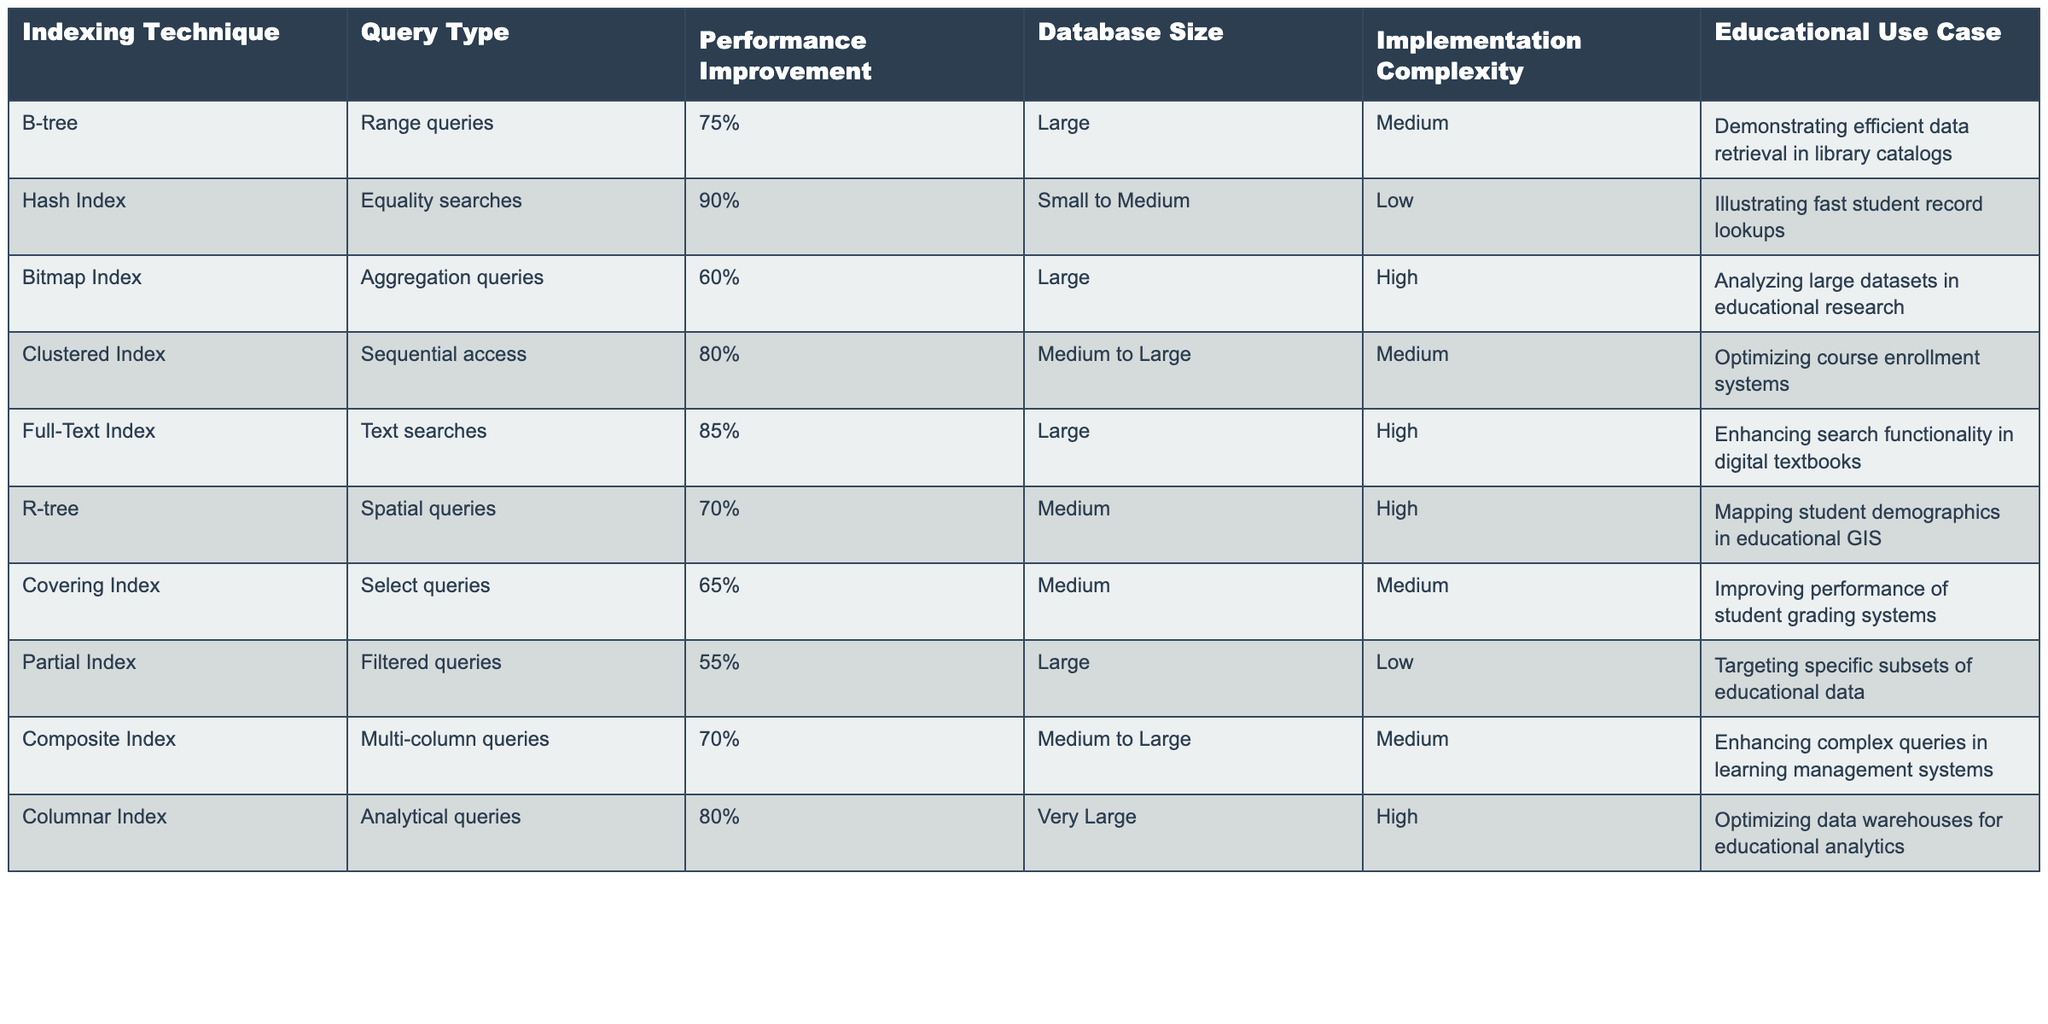What is the performance improvement percentage for B-tree indexing technique? The table shows that the performance improvement for B-tree indexing technique is 75%. This is directly referenced from the corresponding cell under the "Performance Improvement" column for the B-tree row.
Answer: 75% Which indexing technique has the lowest implementation complexity? By examining the "Implementation Complexity" column, the Hash Index technique has a low complexity rating as compared to others like Bitmap Index and Full-Text Index which have high complexity.
Answer: Hash Index What are the average performance improvements of indexes for equality searches versus range queries? The performance improvement for equality searches (Hash Index) is 90%, while for range queries (B-tree) it is 75%. The average for equality searches is 90%, and for range queries, it is 75%. Therefore, the average is (90 + 75) / 2 = 82.5.
Answer: 82.5 Is a Full-Text Index more complex to implement than a Clustered Index? Looking at the "Implementation Complexity" column, Full-Text Index is rated as "High," while Clustered Index is rated as "Medium." Therefore, the statement is true, indicating that Full-Text Index is indeed more complex to implement.
Answer: Yes Which indexing techniques are designed for large databases? By filtering the "Database Size" column, the B-tree, Bitmap Index, Full-Text Index, and Partial Index are explicitly categorized as techniques suitable for large databases. Thus, these four techniques are tailored for large data applications.
Answer: B-tree, Bitmap Index, Full-Text Index, Partial Index If you combine the performance improvements for Clustered Index and Bitmap Index, what is the total? The performance improvement for Clustered Index is 80%, and for Bitmap Index, it is 60%. By adding these two values together, 80 + 60 = 140.
Answer: 140 Does the R-tree indexing technique improve performance for spatial queries? The table indicates that R-tree is specifically designed for spatial queries, and its performance improvement is rated at 70%. Therefore, this technique does enhance performance in this context.
Answer: Yes Which educational use case is associated with the Columnar Index? Referring to the "Educational Use Case" column, the Columnar Index is associated with optimizing data warehouses for educational analytics. This information is directly available in the table.
Answer: Optimizing data warehouses for educational analytics 